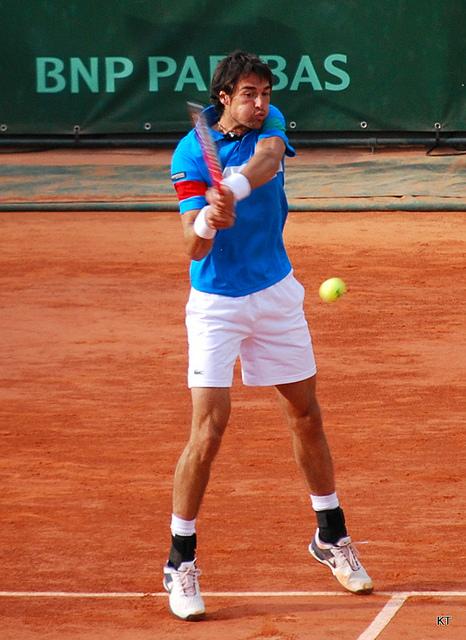Is the man playing baseball?
Concise answer only. No. What are the color of the men's socks?
Concise answer only. White. Is the ball on the ground?
Answer briefly. No. 